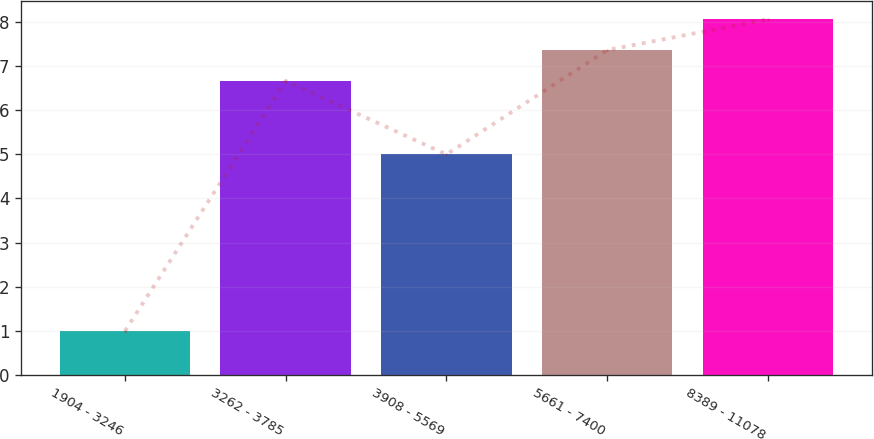<chart> <loc_0><loc_0><loc_500><loc_500><bar_chart><fcel>1904 - 3246<fcel>3262 - 3785<fcel>3908 - 5569<fcel>5661 - 7400<fcel>8389 - 11078<nl><fcel>0.99<fcel>6.67<fcel>5<fcel>7.37<fcel>8.07<nl></chart> 